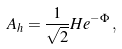Convert formula to latex. <formula><loc_0><loc_0><loc_500><loc_500>A _ { h } = \frac { 1 } { \sqrt { 2 } } H e ^ { - \Phi } \, ,</formula> 